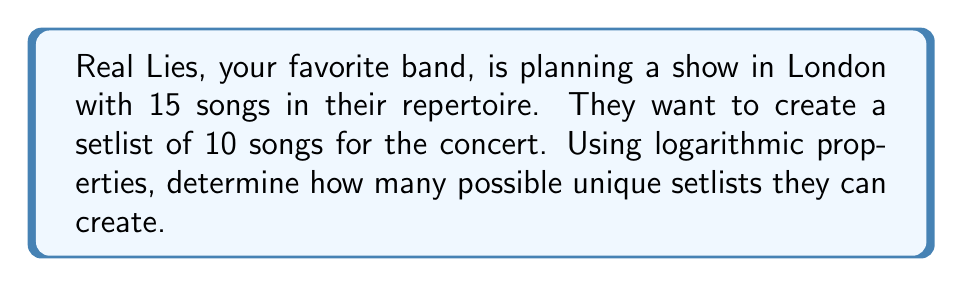Give your solution to this math problem. Let's approach this step-by-step:

1) This is a combination problem. We need to calculate how many ways we can choose 10 songs out of 15.

2) The formula for combinations is:

   $$C(n,r) = \frac{n!}{r!(n-r)!}$$

   Where $n$ is the total number of items (15 songs) and $r$ is the number of items being chosen (10 songs).

3) Substituting our values:

   $$C(15,10) = \frac{15!}{10!(15-10)!} = \frac{15!}{10!5!}$$

4) Expanding this:

   $$\frac{15 \cdot 14 \cdot 13 \cdot 12 \cdot 11 \cdot 10!}{10! \cdot 5 \cdot 4 \cdot 3 \cdot 2 \cdot 1}$$

5) The 10! cancels out in the numerator and denominator:

   $$\frac{15 \cdot 14 \cdot 13 \cdot 12 \cdot 11}{5 \cdot 4 \cdot 3 \cdot 2 \cdot 1}$$

6) Calculating this:

   $$\frac{360360}{120} = 3003$$

7) To express this using logarithms, we can take the log of both sides:

   $$\log(3003) \approx 3.4775$$

8) Using the properties of logarithms, this is equivalent to:

   $$\log(15) + \log(14) + \log(13) + \log(12) + \log(11) - \log(5!) \approx 3.4775$$

Thus, there are 3003 possible setlists, which can be expressed as approximately $10^{3.4775}$.
Answer: $10^{3.4775}$ or 3003 